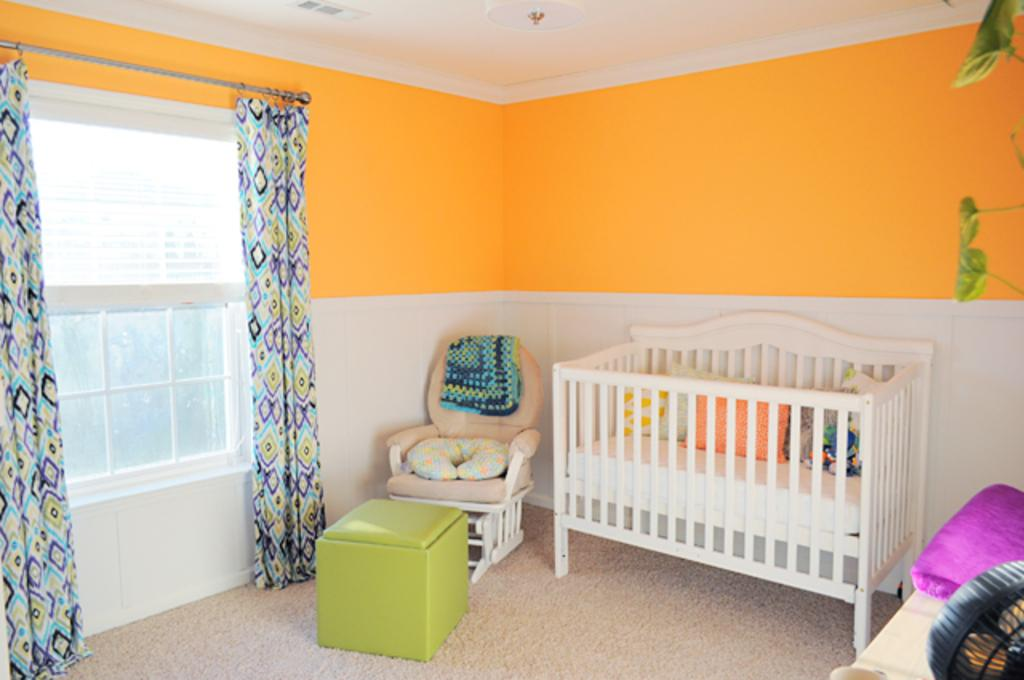What type of furniture is present in the room? There is a bed, a chair, and a table in the room. What is on the bed? The bed has pillows. What is near the window? There are leaves visible near the window. How is the window decorated? The window has two curtains. What type of decision is being made in the room? There is no indication of a decision being made in the room; the image only shows furniture and a window. 